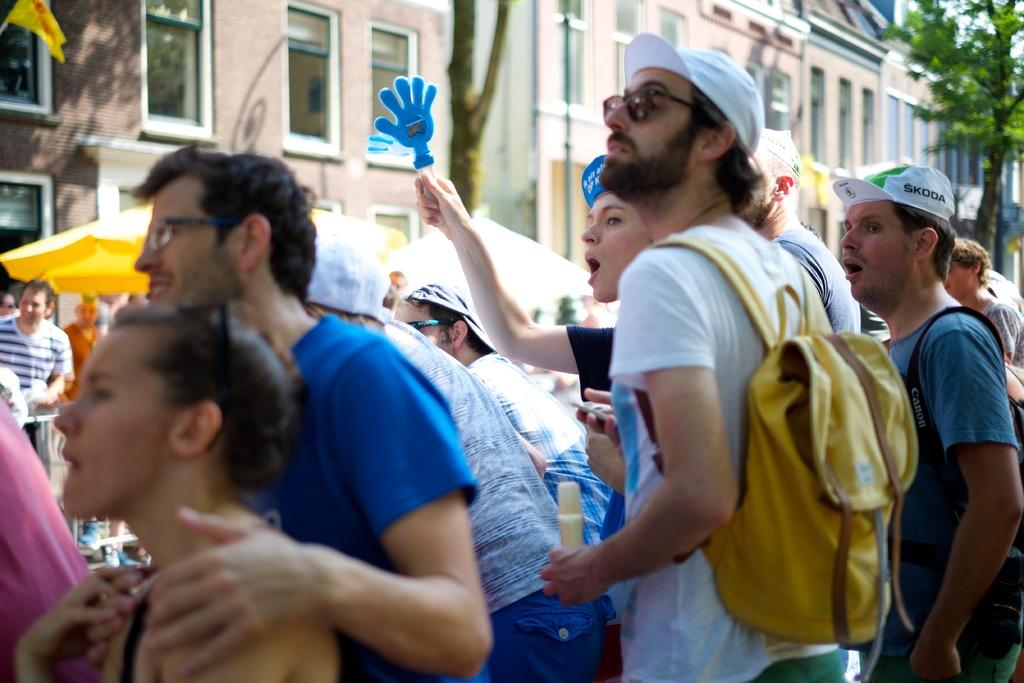What is happening in the image involving people? There is a group of people standing in the image. What objects are visible that the people might be carrying? Bags and umbrellas are visible in the image. What type of headwear is present in the image? Caps are present in the image. What symbol or emblem can be seen in the image? There is a flag in the image. What type of vegetation is present in the image? Trees are present in the image. What type of structures are visible in the background of the image? Buildings with windows are visible in the background of the image. What is the level of friction between the people in the image? There is no information about the level of friction between the people in the image. What is causing the people in the image to feel anger? There is no indication of anger or any negative emotions in the image. 